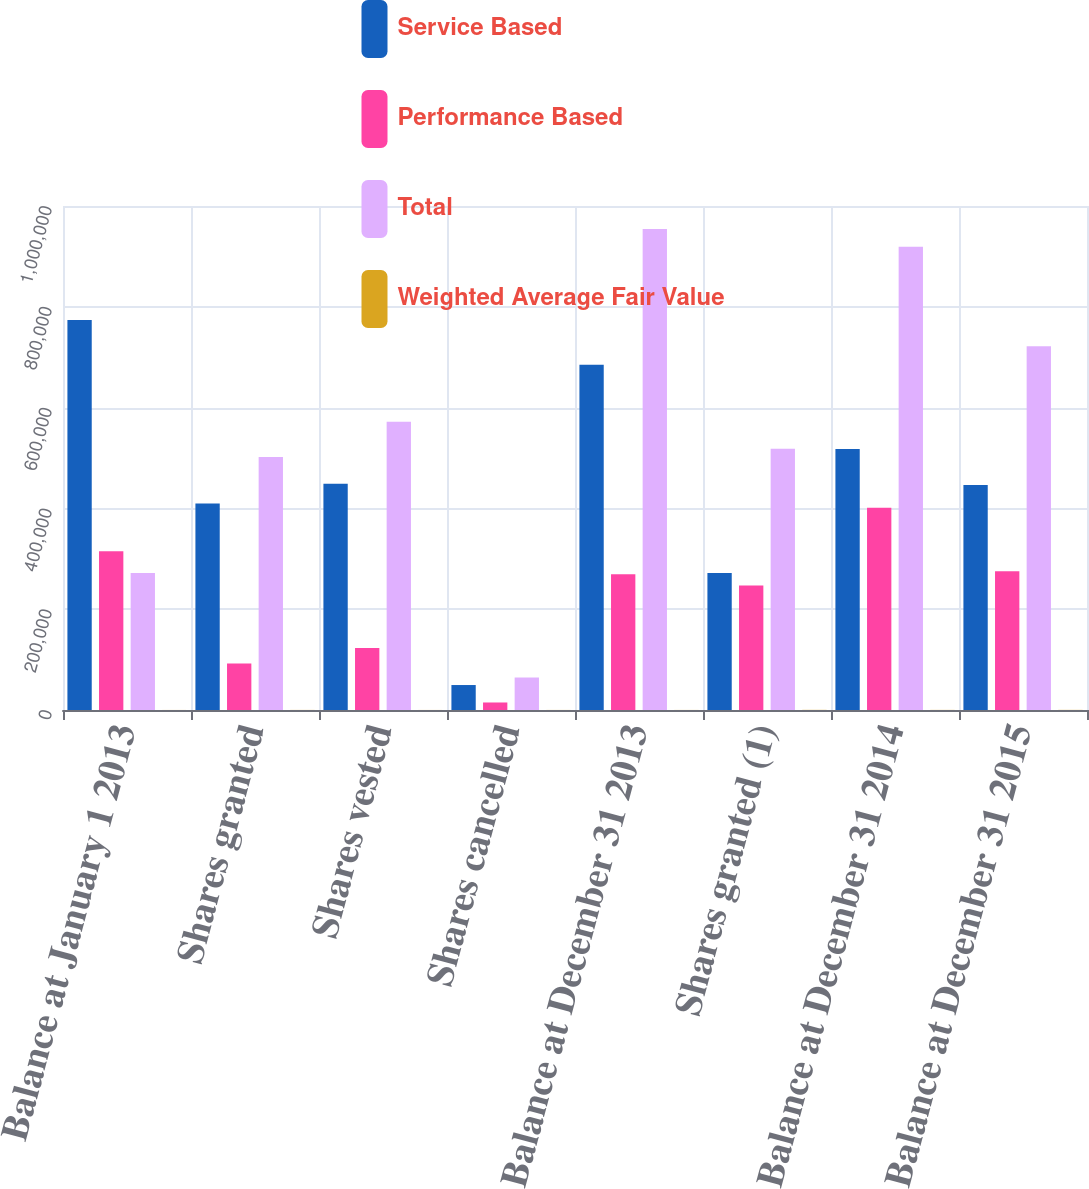<chart> <loc_0><loc_0><loc_500><loc_500><stacked_bar_chart><ecel><fcel>Balance at January 1 2013<fcel>Shares granted<fcel>Shares vested<fcel>Shares cancelled<fcel>Balance at December 31 2013<fcel>Shares granted (1)<fcel>Balance at December 31 2014<fcel>Balance at December 31 2015<nl><fcel>Service Based<fcel>773841<fcel>409575<fcel>448868<fcel>49544<fcel>685004<fcel>271616<fcel>518067<fcel>446366<nl><fcel>Performance Based<fcel>315151<fcel>92206<fcel>122931<fcel>14915<fcel>269511<fcel>246867<fcel>401267<fcel>275538<nl><fcel>Total<fcel>271616<fcel>501781<fcel>571799<fcel>64459<fcel>954515<fcel>518483<fcel>919334<fcel>721904<nl><fcel>Weighted Average Fair Value<fcel>93.33<fcel>155.31<fcel>88.15<fcel>115.83<fcel>121.86<fcel>282.34<fcel>198.85<fcel>238.37<nl></chart> 